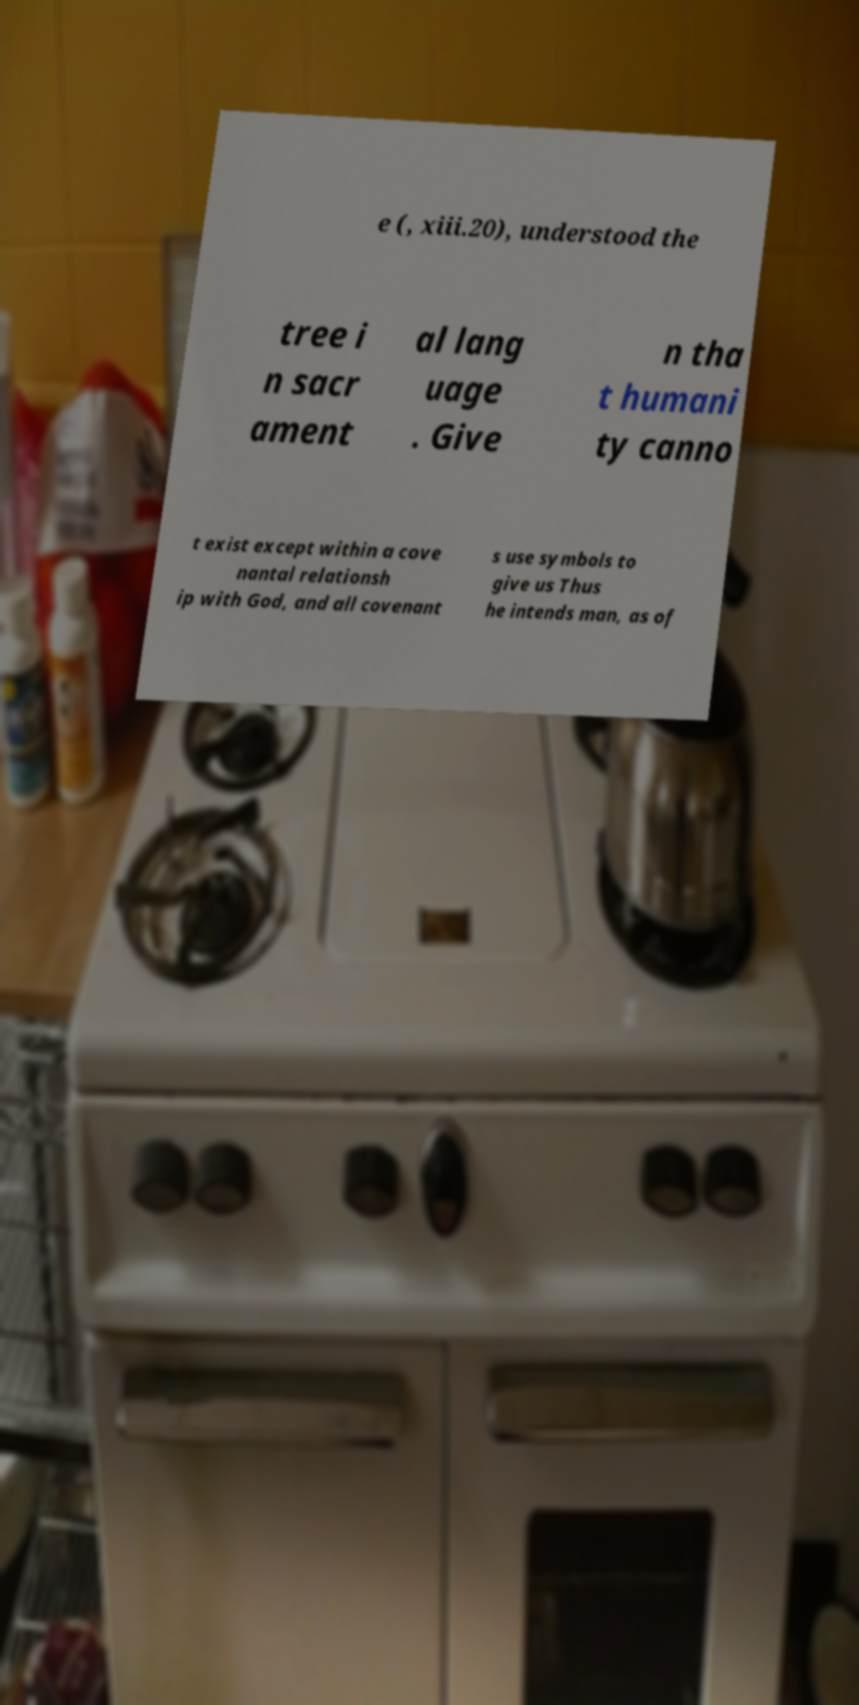I need the written content from this picture converted into text. Can you do that? e (, xiii.20), understood the tree i n sacr ament al lang uage . Give n tha t humani ty canno t exist except within a cove nantal relationsh ip with God, and all covenant s use symbols to give us Thus he intends man, as of 